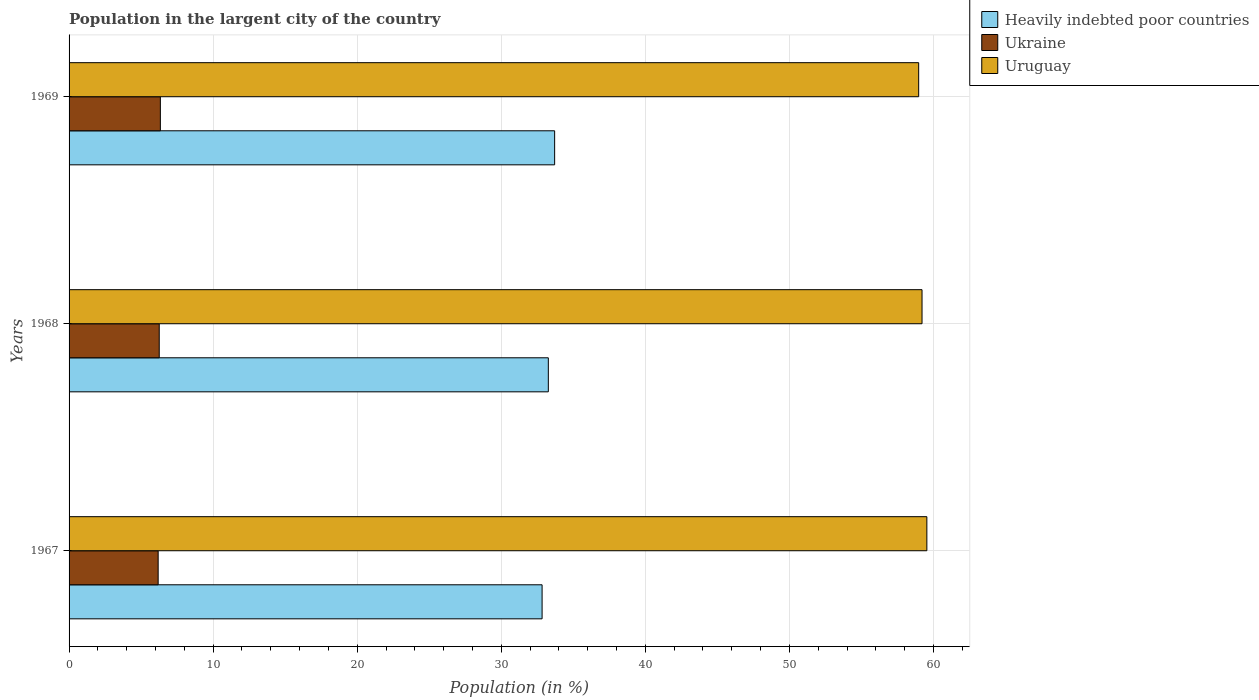How many groups of bars are there?
Offer a very short reply. 3. How many bars are there on the 3rd tick from the top?
Keep it short and to the point. 3. How many bars are there on the 2nd tick from the bottom?
Offer a terse response. 3. What is the label of the 2nd group of bars from the top?
Make the answer very short. 1968. What is the percentage of population in the largent city in Ukraine in 1969?
Offer a terse response. 6.34. Across all years, what is the maximum percentage of population in the largent city in Ukraine?
Your answer should be compact. 6.34. Across all years, what is the minimum percentage of population in the largent city in Ukraine?
Keep it short and to the point. 6.18. In which year was the percentage of population in the largent city in Uruguay maximum?
Your answer should be compact. 1967. In which year was the percentage of population in the largent city in Uruguay minimum?
Your answer should be very brief. 1969. What is the total percentage of population in the largent city in Uruguay in the graph?
Offer a terse response. 177.72. What is the difference between the percentage of population in the largent city in Uruguay in 1967 and that in 1968?
Give a very brief answer. 0.33. What is the difference between the percentage of population in the largent city in Uruguay in 1969 and the percentage of population in the largent city in Ukraine in 1968?
Offer a terse response. 52.72. What is the average percentage of population in the largent city in Uruguay per year?
Provide a succinct answer. 59.24. In the year 1969, what is the difference between the percentage of population in the largent city in Uruguay and percentage of population in the largent city in Heavily indebted poor countries?
Provide a succinct answer. 25.27. In how many years, is the percentage of population in the largent city in Ukraine greater than 24 %?
Provide a short and direct response. 0. What is the ratio of the percentage of population in the largent city in Ukraine in 1968 to that in 1969?
Ensure brevity in your answer.  0.99. Is the difference between the percentage of population in the largent city in Uruguay in 1968 and 1969 greater than the difference between the percentage of population in the largent city in Heavily indebted poor countries in 1968 and 1969?
Your answer should be very brief. Yes. What is the difference between the highest and the second highest percentage of population in the largent city in Ukraine?
Provide a short and direct response. 0.08. What is the difference between the highest and the lowest percentage of population in the largent city in Heavily indebted poor countries?
Your answer should be compact. 0.87. Is the sum of the percentage of population in the largent city in Uruguay in 1967 and 1969 greater than the maximum percentage of population in the largent city in Heavily indebted poor countries across all years?
Ensure brevity in your answer.  Yes. What does the 2nd bar from the top in 1968 represents?
Offer a very short reply. Ukraine. What does the 1st bar from the bottom in 1967 represents?
Provide a short and direct response. Heavily indebted poor countries. Is it the case that in every year, the sum of the percentage of population in the largent city in Heavily indebted poor countries and percentage of population in the largent city in Ukraine is greater than the percentage of population in the largent city in Uruguay?
Your answer should be very brief. No. How many bars are there?
Ensure brevity in your answer.  9. Are all the bars in the graph horizontal?
Your response must be concise. Yes. How many years are there in the graph?
Your answer should be very brief. 3. What is the difference between two consecutive major ticks on the X-axis?
Keep it short and to the point. 10. Are the values on the major ticks of X-axis written in scientific E-notation?
Provide a short and direct response. No. Does the graph contain any zero values?
Your answer should be compact. No. Where does the legend appear in the graph?
Keep it short and to the point. Top right. How many legend labels are there?
Your answer should be very brief. 3. What is the title of the graph?
Your answer should be compact. Population in the largent city of the country. What is the label or title of the Y-axis?
Give a very brief answer. Years. What is the Population (in %) of Heavily indebted poor countries in 1967?
Make the answer very short. 32.83. What is the Population (in %) of Ukraine in 1967?
Make the answer very short. 6.18. What is the Population (in %) in Uruguay in 1967?
Your answer should be compact. 59.54. What is the Population (in %) in Heavily indebted poor countries in 1968?
Ensure brevity in your answer.  33.27. What is the Population (in %) in Ukraine in 1968?
Offer a very short reply. 6.26. What is the Population (in %) in Uruguay in 1968?
Your answer should be very brief. 59.21. What is the Population (in %) in Heavily indebted poor countries in 1969?
Provide a succinct answer. 33.71. What is the Population (in %) in Ukraine in 1969?
Give a very brief answer. 6.34. What is the Population (in %) of Uruguay in 1969?
Keep it short and to the point. 58.97. Across all years, what is the maximum Population (in %) in Heavily indebted poor countries?
Keep it short and to the point. 33.71. Across all years, what is the maximum Population (in %) in Ukraine?
Your answer should be very brief. 6.34. Across all years, what is the maximum Population (in %) of Uruguay?
Make the answer very short. 59.54. Across all years, what is the minimum Population (in %) of Heavily indebted poor countries?
Make the answer very short. 32.83. Across all years, what is the minimum Population (in %) of Ukraine?
Keep it short and to the point. 6.18. Across all years, what is the minimum Population (in %) of Uruguay?
Ensure brevity in your answer.  58.97. What is the total Population (in %) in Heavily indebted poor countries in the graph?
Your answer should be very brief. 99.81. What is the total Population (in %) of Ukraine in the graph?
Ensure brevity in your answer.  18.78. What is the total Population (in %) in Uruguay in the graph?
Ensure brevity in your answer.  177.72. What is the difference between the Population (in %) of Heavily indebted poor countries in 1967 and that in 1968?
Keep it short and to the point. -0.43. What is the difference between the Population (in %) of Ukraine in 1967 and that in 1968?
Your answer should be compact. -0.07. What is the difference between the Population (in %) in Uruguay in 1967 and that in 1968?
Provide a short and direct response. 0.33. What is the difference between the Population (in %) in Heavily indebted poor countries in 1967 and that in 1969?
Provide a succinct answer. -0.87. What is the difference between the Population (in %) of Ukraine in 1967 and that in 1969?
Keep it short and to the point. -0.15. What is the difference between the Population (in %) of Uruguay in 1967 and that in 1969?
Ensure brevity in your answer.  0.57. What is the difference between the Population (in %) in Heavily indebted poor countries in 1968 and that in 1969?
Provide a short and direct response. -0.44. What is the difference between the Population (in %) of Ukraine in 1968 and that in 1969?
Make the answer very short. -0.08. What is the difference between the Population (in %) of Uruguay in 1968 and that in 1969?
Give a very brief answer. 0.23. What is the difference between the Population (in %) in Heavily indebted poor countries in 1967 and the Population (in %) in Ukraine in 1968?
Your response must be concise. 26.58. What is the difference between the Population (in %) in Heavily indebted poor countries in 1967 and the Population (in %) in Uruguay in 1968?
Your answer should be very brief. -26.37. What is the difference between the Population (in %) in Ukraine in 1967 and the Population (in %) in Uruguay in 1968?
Make the answer very short. -53.02. What is the difference between the Population (in %) of Heavily indebted poor countries in 1967 and the Population (in %) of Ukraine in 1969?
Make the answer very short. 26.5. What is the difference between the Population (in %) in Heavily indebted poor countries in 1967 and the Population (in %) in Uruguay in 1969?
Your response must be concise. -26.14. What is the difference between the Population (in %) of Ukraine in 1967 and the Population (in %) of Uruguay in 1969?
Provide a short and direct response. -52.79. What is the difference between the Population (in %) in Heavily indebted poor countries in 1968 and the Population (in %) in Ukraine in 1969?
Provide a succinct answer. 26.93. What is the difference between the Population (in %) in Heavily indebted poor countries in 1968 and the Population (in %) in Uruguay in 1969?
Your answer should be compact. -25.71. What is the difference between the Population (in %) of Ukraine in 1968 and the Population (in %) of Uruguay in 1969?
Your answer should be very brief. -52.72. What is the average Population (in %) in Heavily indebted poor countries per year?
Your answer should be compact. 33.27. What is the average Population (in %) in Ukraine per year?
Your response must be concise. 6.26. What is the average Population (in %) of Uruguay per year?
Offer a terse response. 59.24. In the year 1967, what is the difference between the Population (in %) of Heavily indebted poor countries and Population (in %) of Ukraine?
Provide a succinct answer. 26.65. In the year 1967, what is the difference between the Population (in %) of Heavily indebted poor countries and Population (in %) of Uruguay?
Your answer should be very brief. -26.71. In the year 1967, what is the difference between the Population (in %) in Ukraine and Population (in %) in Uruguay?
Make the answer very short. -53.36. In the year 1968, what is the difference between the Population (in %) of Heavily indebted poor countries and Population (in %) of Ukraine?
Keep it short and to the point. 27.01. In the year 1968, what is the difference between the Population (in %) of Heavily indebted poor countries and Population (in %) of Uruguay?
Offer a very short reply. -25.94. In the year 1968, what is the difference between the Population (in %) in Ukraine and Population (in %) in Uruguay?
Your answer should be very brief. -52.95. In the year 1969, what is the difference between the Population (in %) of Heavily indebted poor countries and Population (in %) of Ukraine?
Keep it short and to the point. 27.37. In the year 1969, what is the difference between the Population (in %) of Heavily indebted poor countries and Population (in %) of Uruguay?
Provide a short and direct response. -25.27. In the year 1969, what is the difference between the Population (in %) of Ukraine and Population (in %) of Uruguay?
Your answer should be very brief. -52.64. What is the ratio of the Population (in %) in Heavily indebted poor countries in 1967 to that in 1968?
Your answer should be compact. 0.99. What is the ratio of the Population (in %) of Ukraine in 1967 to that in 1968?
Provide a short and direct response. 0.99. What is the ratio of the Population (in %) of Uruguay in 1967 to that in 1968?
Keep it short and to the point. 1.01. What is the ratio of the Population (in %) of Heavily indebted poor countries in 1967 to that in 1969?
Your answer should be very brief. 0.97. What is the ratio of the Population (in %) in Ukraine in 1967 to that in 1969?
Provide a short and direct response. 0.98. What is the ratio of the Population (in %) of Uruguay in 1967 to that in 1969?
Offer a terse response. 1.01. What is the ratio of the Population (in %) of Heavily indebted poor countries in 1968 to that in 1969?
Ensure brevity in your answer.  0.99. What is the ratio of the Population (in %) in Ukraine in 1968 to that in 1969?
Provide a short and direct response. 0.99. What is the ratio of the Population (in %) in Uruguay in 1968 to that in 1969?
Offer a terse response. 1. What is the difference between the highest and the second highest Population (in %) of Heavily indebted poor countries?
Provide a short and direct response. 0.44. What is the difference between the highest and the second highest Population (in %) in Ukraine?
Make the answer very short. 0.08. What is the difference between the highest and the second highest Population (in %) in Uruguay?
Offer a terse response. 0.33. What is the difference between the highest and the lowest Population (in %) in Heavily indebted poor countries?
Offer a terse response. 0.87. What is the difference between the highest and the lowest Population (in %) in Ukraine?
Your answer should be compact. 0.15. What is the difference between the highest and the lowest Population (in %) of Uruguay?
Your response must be concise. 0.57. 